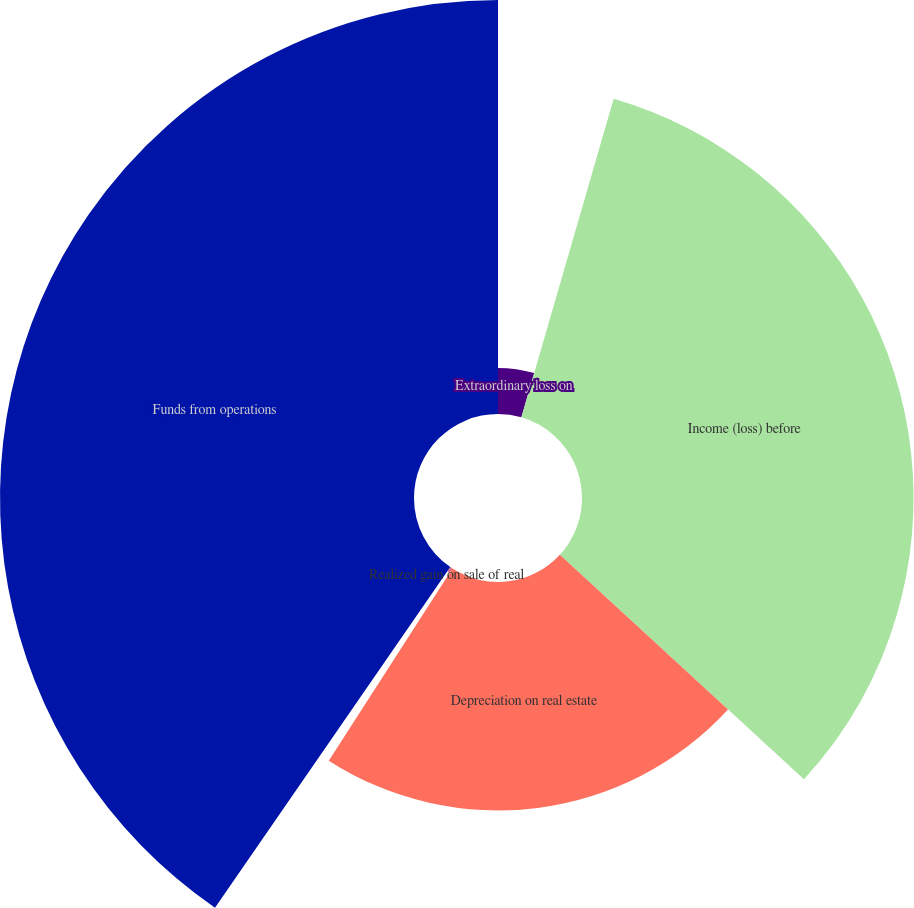Convert chart to OTSL. <chart><loc_0><loc_0><loc_500><loc_500><pie_chart><fcel>Extraordinary loss on<fcel>Income (loss) before<fcel>Depreciation on real estate<fcel>Realized gain on sale of real<fcel>Funds from operations<nl><fcel>4.49%<fcel>32.34%<fcel>22.28%<fcel>0.51%<fcel>40.38%<nl></chart> 